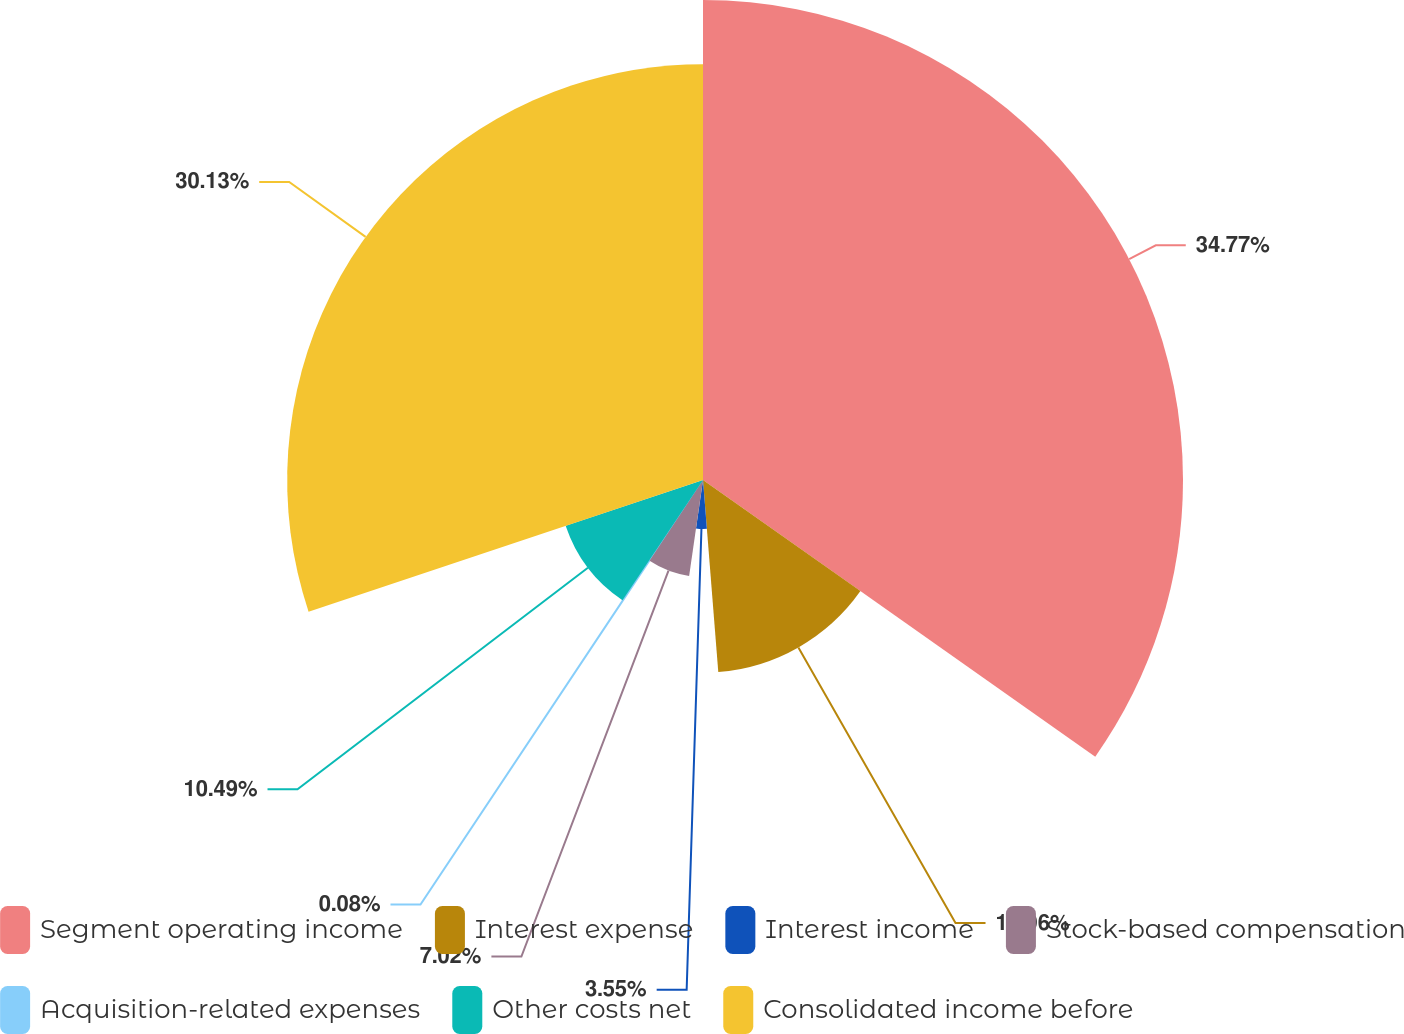Convert chart to OTSL. <chart><loc_0><loc_0><loc_500><loc_500><pie_chart><fcel>Segment operating income<fcel>Interest expense<fcel>Interest income<fcel>Stock-based compensation<fcel>Acquisition-related expenses<fcel>Other costs net<fcel>Consolidated income before<nl><fcel>34.78%<fcel>13.96%<fcel>3.55%<fcel>7.02%<fcel>0.08%<fcel>10.49%<fcel>30.13%<nl></chart> 